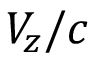<formula> <loc_0><loc_0><loc_500><loc_500>V _ { z } / c</formula> 